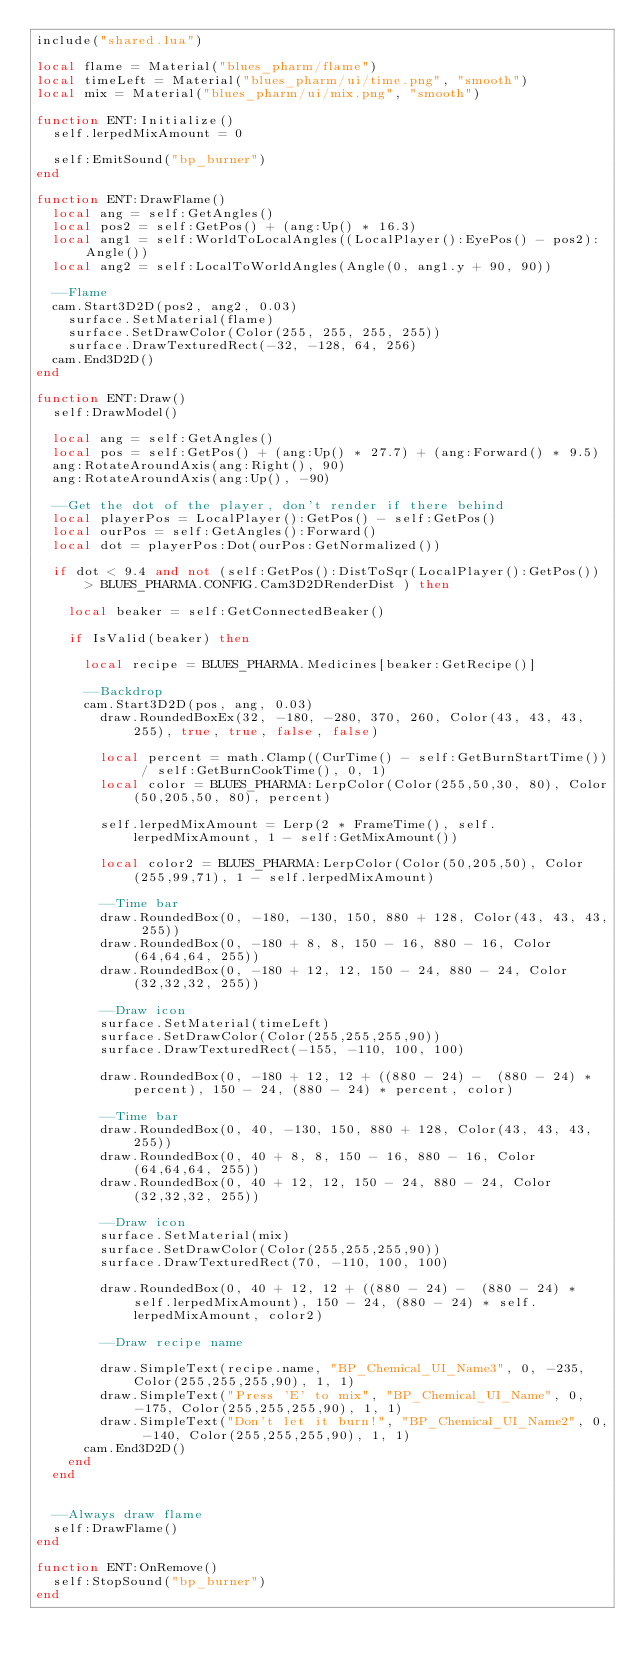<code> <loc_0><loc_0><loc_500><loc_500><_Lua_>include("shared.lua")

local flame = Material("blues_pharm/flame")
local timeLeft = Material("blues_pharm/ui/time.png", "smooth")
local mix = Material("blues_pharm/ui/mix.png", "smooth")

function ENT:Initialize()
	self.lerpedMixAmount = 0

	self:EmitSound("bp_burner")
end

function ENT:DrawFlame()
	local ang = self:GetAngles()
	local pos2 = self:GetPos() + (ang:Up() * 16.3)
	local ang1 = self:WorldToLocalAngles((LocalPlayer():EyePos() - pos2):Angle())
	local ang2 = self:LocalToWorldAngles(Angle(0, ang1.y + 90, 90))

	--Flame
	cam.Start3D2D(pos2, ang2, 0.03)
		surface.SetMaterial(flame)
		surface.SetDrawColor(Color(255, 255, 255, 255))
		surface.DrawTexturedRect(-32, -128, 64, 256)
	cam.End3D2D()
end

function ENT:Draw()
	self:DrawModel()

	local ang = self:GetAngles()
	local pos = self:GetPos() + (ang:Up() * 27.7) + (ang:Forward() * 9.5)
	ang:RotateAroundAxis(ang:Right(), 90)
	ang:RotateAroundAxis(ang:Up(), -90)

	--Get the dot of the player, don't render if there behind
	local playerPos = LocalPlayer():GetPos() - self:GetPos()
	local ourPos = self:GetAngles():Forward()
	local dot = playerPos:Dot(ourPos:GetNormalized())

	if dot < 9.4 and not (self:GetPos():DistToSqr(LocalPlayer():GetPos()) > BLUES_PHARMA.CONFIG.Cam3D2DRenderDist ) then

		local beaker = self:GetConnectedBeaker()

		if IsValid(beaker) then

			local recipe = BLUES_PHARMA.Medicines[beaker:GetRecipe()]

			--Backdrop
			cam.Start3D2D(pos, ang, 0.03)
				draw.RoundedBoxEx(32, -180, -280, 370, 260, Color(43, 43, 43, 255), true, true, false, false)

				local percent = math.Clamp((CurTime() - self:GetBurnStartTime()) / self:GetBurnCookTime(), 0, 1)
				local color = BLUES_PHARMA:LerpColor(Color(255,50,30, 80), Color(50,205,50, 80), percent)

				self.lerpedMixAmount = Lerp(2 * FrameTime(), self.lerpedMixAmount, 1 - self:GetMixAmount())

				local color2 = BLUES_PHARMA:LerpColor(Color(50,205,50), Color(255,99,71), 1 - self.lerpedMixAmount)

				--Time bar
				draw.RoundedBox(0, -180, -130, 150, 880 + 128, Color(43, 43, 43, 255))
				draw.RoundedBox(0, -180 + 8, 8, 150 - 16, 880 - 16, Color(64,64,64, 255))
				draw.RoundedBox(0, -180 + 12, 12, 150 - 24, 880 - 24, Color(32,32,32, 255))

				--Draw icon
				surface.SetMaterial(timeLeft)
				surface.SetDrawColor(Color(255,255,255,90))
				surface.DrawTexturedRect(-155, -110, 100, 100)

				draw.RoundedBox(0, -180 + 12, 12 + ((880 - 24) -  (880 - 24) * percent), 150 - 24, (880 - 24) * percent, color)

				--Time bar
				draw.RoundedBox(0, 40, -130, 150, 880 + 128, Color(43, 43, 43, 255))
				draw.RoundedBox(0, 40 + 8, 8, 150 - 16, 880 - 16, Color(64,64,64, 255))
				draw.RoundedBox(0, 40 + 12, 12, 150 - 24, 880 - 24, Color(32,32,32, 255))

				--Draw icon
				surface.SetMaterial(mix)
				surface.SetDrawColor(Color(255,255,255,90))
				surface.DrawTexturedRect(70, -110, 100, 100)

				draw.RoundedBox(0, 40 + 12, 12 + ((880 - 24) -  (880 - 24) * self.lerpedMixAmount), 150 - 24, (880 - 24) * self.lerpedMixAmount, color2)

				--Draw recipe name

				draw.SimpleText(recipe.name, "BP_Chemical_UI_Name3", 0, -235, Color(255,255,255,90), 1, 1)
				draw.SimpleText("Press 'E' to mix", "BP_Chemical_UI_Name", 0, -175, Color(255,255,255,90), 1, 1)
				draw.SimpleText("Don't let it burn!", "BP_Chemical_UI_Name2", 0, -140, Color(255,255,255,90), 1, 1)
			cam.End3D2D()
		end
	end


	--Always draw flame
	self:DrawFlame()
end

function ENT:OnRemove()
	self:StopSound("bp_burner")
end</code> 